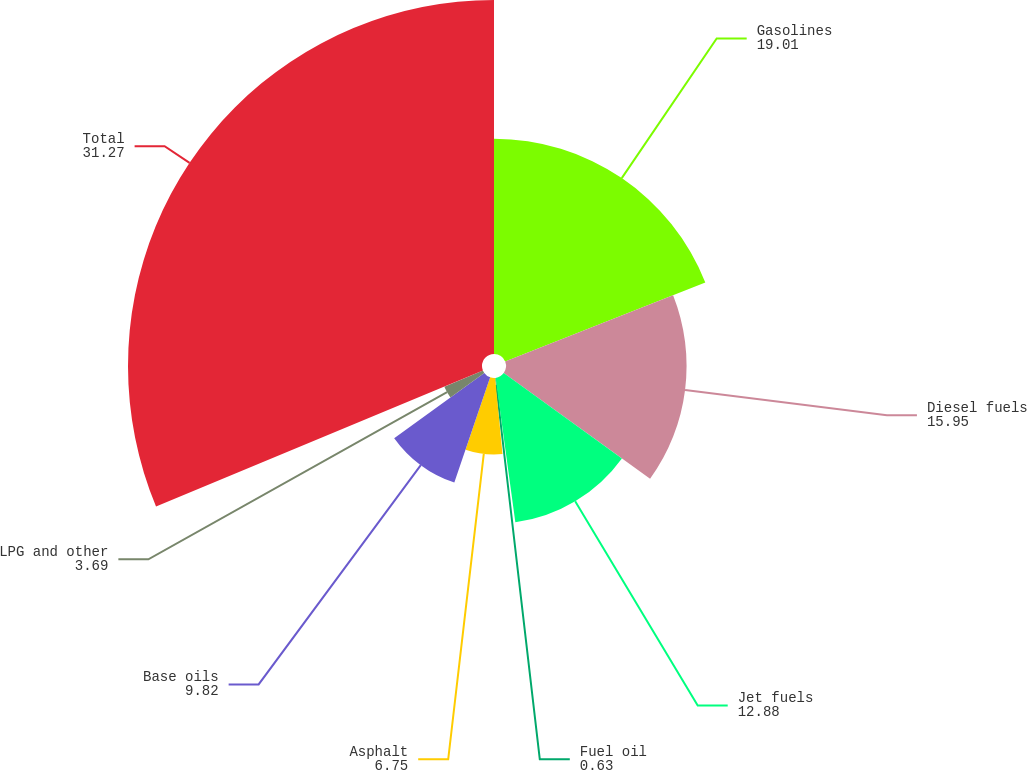<chart> <loc_0><loc_0><loc_500><loc_500><pie_chart><fcel>Gasolines<fcel>Diesel fuels<fcel>Jet fuels<fcel>Fuel oil<fcel>Asphalt<fcel>Base oils<fcel>LPG and other<fcel>Total<nl><fcel>19.01%<fcel>15.95%<fcel>12.88%<fcel>0.63%<fcel>6.75%<fcel>9.82%<fcel>3.69%<fcel>31.27%<nl></chart> 